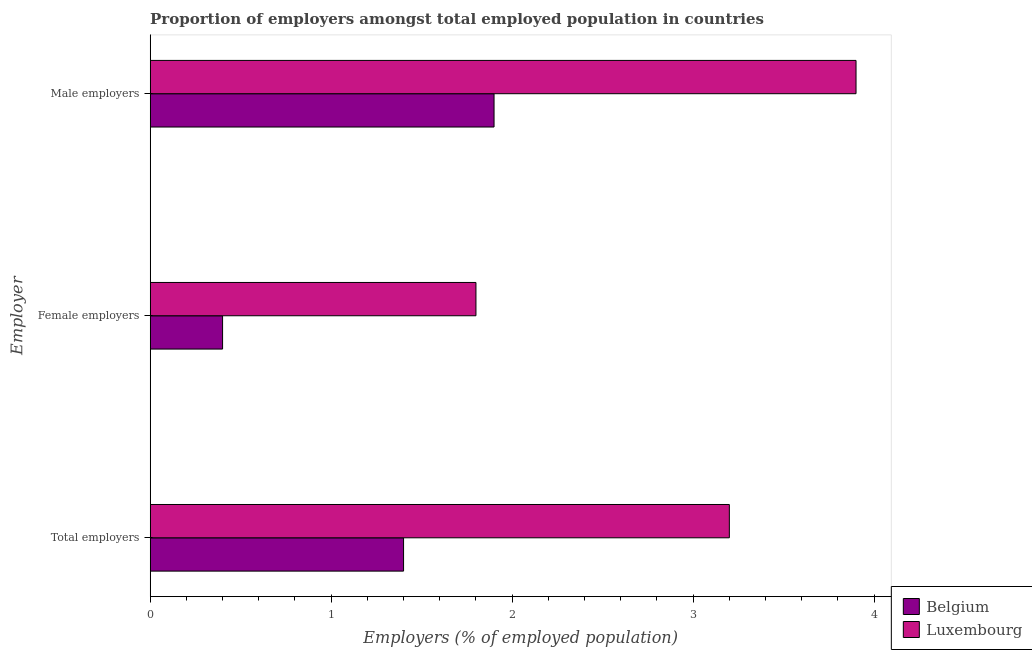How many different coloured bars are there?
Keep it short and to the point. 2. How many groups of bars are there?
Ensure brevity in your answer.  3. Are the number of bars per tick equal to the number of legend labels?
Ensure brevity in your answer.  Yes. What is the label of the 2nd group of bars from the top?
Your response must be concise. Female employers. What is the percentage of male employers in Luxembourg?
Offer a very short reply. 3.9. Across all countries, what is the maximum percentage of total employers?
Ensure brevity in your answer.  3.2. Across all countries, what is the minimum percentage of total employers?
Provide a succinct answer. 1.4. In which country was the percentage of male employers maximum?
Give a very brief answer. Luxembourg. In which country was the percentage of female employers minimum?
Your answer should be compact. Belgium. What is the total percentage of total employers in the graph?
Give a very brief answer. 4.6. What is the difference between the percentage of male employers in Belgium and that in Luxembourg?
Ensure brevity in your answer.  -2. What is the difference between the percentage of male employers in Belgium and the percentage of total employers in Luxembourg?
Give a very brief answer. -1.3. What is the average percentage of total employers per country?
Your response must be concise. 2.3. What is the difference between the percentage of female employers and percentage of male employers in Luxembourg?
Give a very brief answer. -2.1. What is the ratio of the percentage of female employers in Luxembourg to that in Belgium?
Ensure brevity in your answer.  4.5. Is the percentage of total employers in Belgium less than that in Luxembourg?
Ensure brevity in your answer.  Yes. What is the difference between the highest and the second highest percentage of female employers?
Offer a very short reply. 1.4. What is the difference between the highest and the lowest percentage of female employers?
Offer a very short reply. 1.4. Is the sum of the percentage of total employers in Belgium and Luxembourg greater than the maximum percentage of male employers across all countries?
Keep it short and to the point. Yes. What does the 1st bar from the top in Female employers represents?
Give a very brief answer. Luxembourg. What does the 2nd bar from the bottom in Male employers represents?
Provide a short and direct response. Luxembourg. Is it the case that in every country, the sum of the percentage of total employers and percentage of female employers is greater than the percentage of male employers?
Make the answer very short. No. How many bars are there?
Your answer should be very brief. 6. Are all the bars in the graph horizontal?
Your response must be concise. Yes. Are the values on the major ticks of X-axis written in scientific E-notation?
Provide a short and direct response. No. Does the graph contain any zero values?
Offer a very short reply. No. Does the graph contain grids?
Provide a short and direct response. No. Where does the legend appear in the graph?
Provide a short and direct response. Bottom right. How are the legend labels stacked?
Provide a short and direct response. Vertical. What is the title of the graph?
Ensure brevity in your answer.  Proportion of employers amongst total employed population in countries. Does "Timor-Leste" appear as one of the legend labels in the graph?
Provide a short and direct response. No. What is the label or title of the X-axis?
Offer a very short reply. Employers (% of employed population). What is the label or title of the Y-axis?
Provide a succinct answer. Employer. What is the Employers (% of employed population) in Belgium in Total employers?
Your answer should be compact. 1.4. What is the Employers (% of employed population) in Luxembourg in Total employers?
Your answer should be very brief. 3.2. What is the Employers (% of employed population) in Belgium in Female employers?
Your response must be concise. 0.4. What is the Employers (% of employed population) in Luxembourg in Female employers?
Provide a succinct answer. 1.8. What is the Employers (% of employed population) in Belgium in Male employers?
Provide a short and direct response. 1.9. What is the Employers (% of employed population) in Luxembourg in Male employers?
Give a very brief answer. 3.9. Across all Employer, what is the maximum Employers (% of employed population) in Belgium?
Provide a succinct answer. 1.9. Across all Employer, what is the maximum Employers (% of employed population) in Luxembourg?
Provide a succinct answer. 3.9. Across all Employer, what is the minimum Employers (% of employed population) of Belgium?
Offer a very short reply. 0.4. Across all Employer, what is the minimum Employers (% of employed population) of Luxembourg?
Your response must be concise. 1.8. What is the total Employers (% of employed population) of Luxembourg in the graph?
Keep it short and to the point. 8.9. What is the difference between the Employers (% of employed population) of Belgium in Total employers and that in Female employers?
Offer a terse response. 1. What is the difference between the Employers (% of employed population) in Luxembourg in Total employers and that in Female employers?
Your response must be concise. 1.4. What is the difference between the Employers (% of employed population) of Belgium in Female employers and that in Male employers?
Offer a very short reply. -1.5. What is the difference between the Employers (% of employed population) of Luxembourg in Female employers and that in Male employers?
Offer a terse response. -2.1. What is the difference between the Employers (% of employed population) of Belgium in Total employers and the Employers (% of employed population) of Luxembourg in Female employers?
Your response must be concise. -0.4. What is the difference between the Employers (% of employed population) in Belgium in Total employers and the Employers (% of employed population) in Luxembourg in Male employers?
Make the answer very short. -2.5. What is the average Employers (% of employed population) in Belgium per Employer?
Your answer should be very brief. 1.23. What is the average Employers (% of employed population) in Luxembourg per Employer?
Make the answer very short. 2.97. What is the ratio of the Employers (% of employed population) in Luxembourg in Total employers to that in Female employers?
Make the answer very short. 1.78. What is the ratio of the Employers (% of employed population) of Belgium in Total employers to that in Male employers?
Keep it short and to the point. 0.74. What is the ratio of the Employers (% of employed population) in Luxembourg in Total employers to that in Male employers?
Provide a succinct answer. 0.82. What is the ratio of the Employers (% of employed population) in Belgium in Female employers to that in Male employers?
Provide a succinct answer. 0.21. What is the ratio of the Employers (% of employed population) of Luxembourg in Female employers to that in Male employers?
Offer a terse response. 0.46. What is the difference between the highest and the second highest Employers (% of employed population) of Luxembourg?
Give a very brief answer. 0.7. What is the difference between the highest and the lowest Employers (% of employed population) of Luxembourg?
Provide a short and direct response. 2.1. 